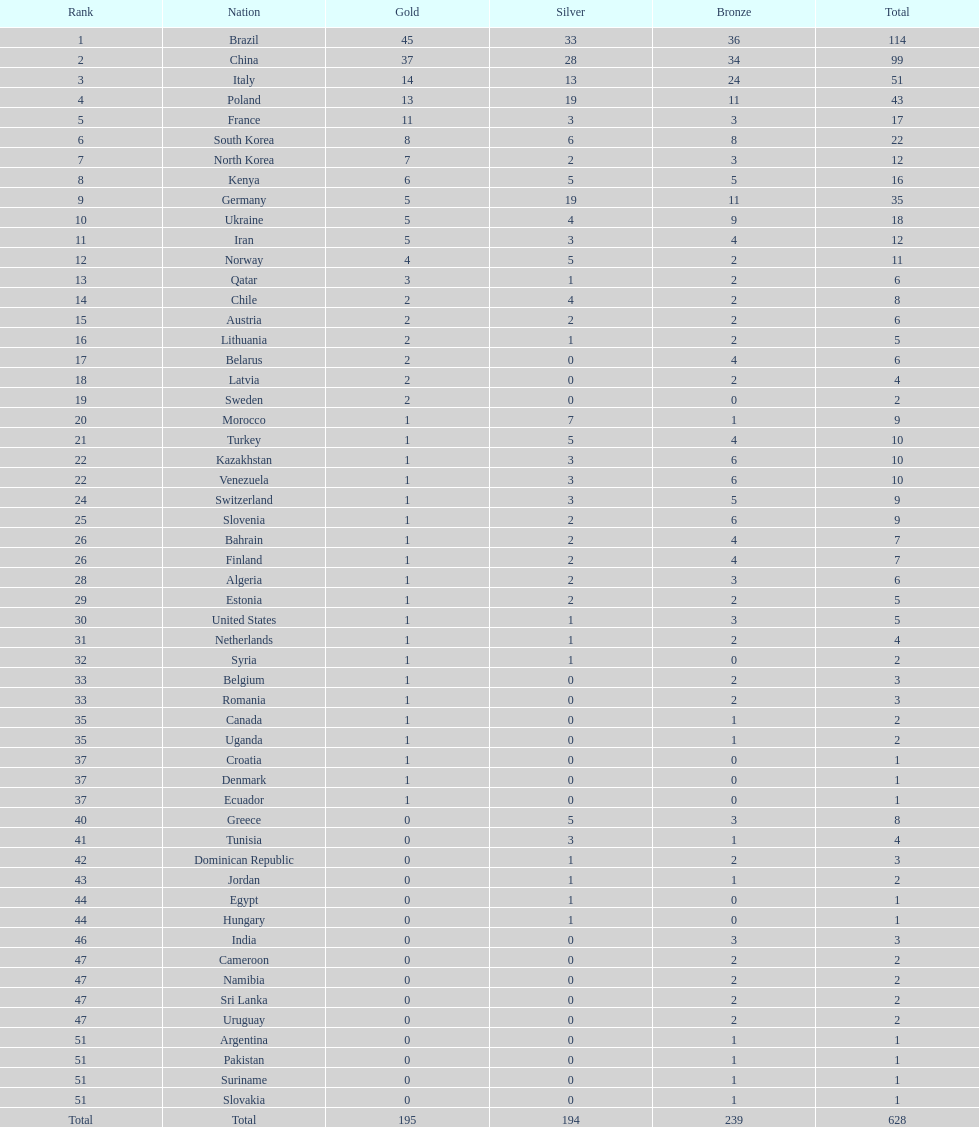How many cumulative medals has norway won? 11. 